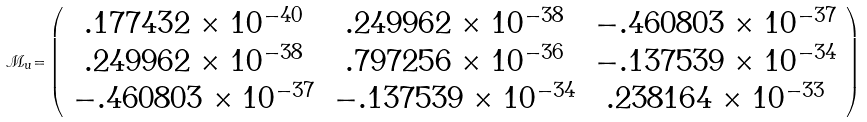Convert formula to latex. <formula><loc_0><loc_0><loc_500><loc_500>\mathcal { M _ { \mathnormal u } } \mathnormal = \left ( \begin{array} { c c c } . 1 7 7 4 3 2 \times 1 0 ^ { - 4 0 } & . 2 4 9 9 6 2 \times 1 0 ^ { - 3 8 } & - . 4 6 0 8 0 3 \times 1 0 ^ { - 3 7 } \\ . 2 4 9 9 6 2 \times 1 0 ^ { - 3 8 } & . 7 9 7 2 5 6 \times 1 0 ^ { - 3 6 } & - . 1 3 7 5 3 9 \times 1 0 ^ { - 3 4 } \\ - . 4 6 0 8 0 3 \times 1 0 ^ { - 3 7 } & - . 1 3 7 5 3 9 \times 1 0 ^ { - 3 4 } & . 2 3 8 1 6 4 \times 1 0 ^ { - 3 3 } \end{array} \right )</formula> 